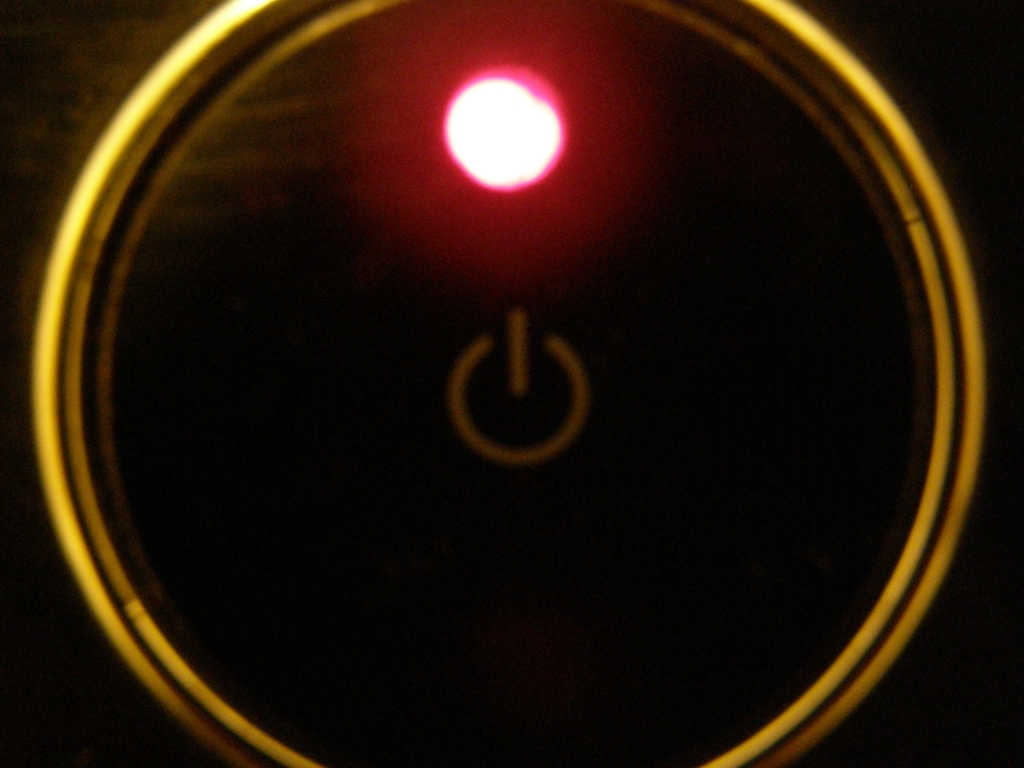Could the lack of focus have been an intentional choice by the photographer? Yes, it's entirely possible that the photographer chose a shallow depth of field to intentionally blur the background, thus directing the viewer's attention towards the power button. This selective focus can be a creative technique to emphasize the subject and create a specific aesthetic or emotional impact. 